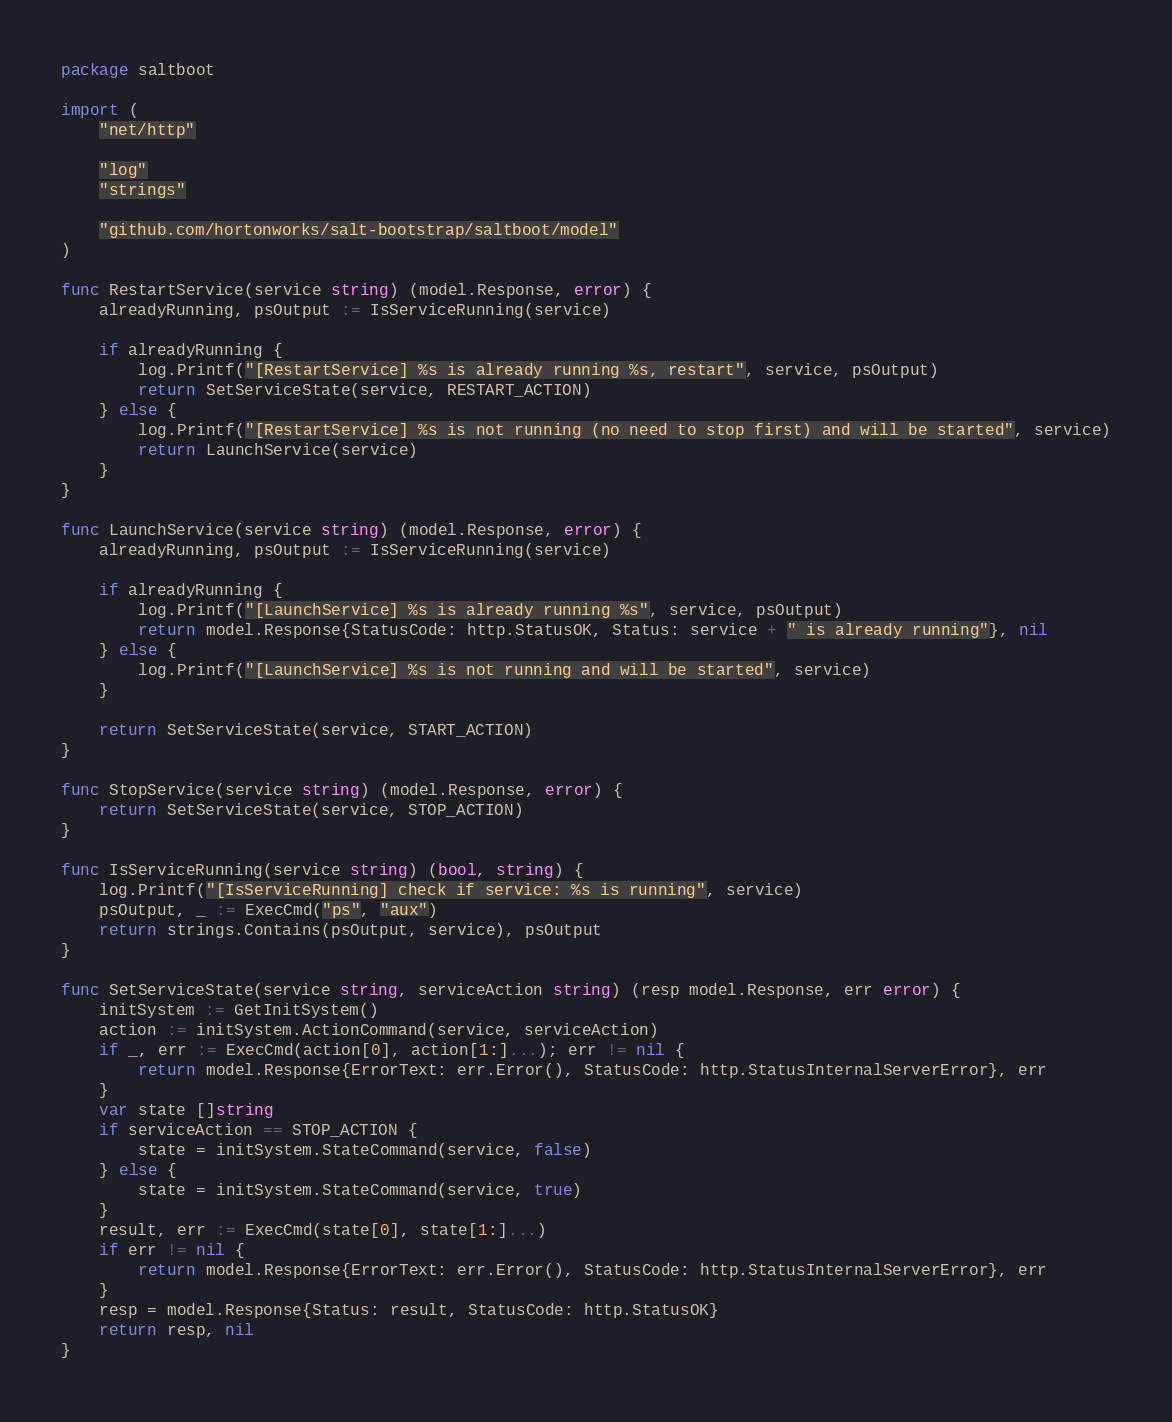Convert code to text. <code><loc_0><loc_0><loc_500><loc_500><_Go_>package saltboot

import (
	"net/http"

	"log"
	"strings"

	"github.com/hortonworks/salt-bootstrap/saltboot/model"
)

func RestartService(service string) (model.Response, error) {
	alreadyRunning, psOutput := IsServiceRunning(service)

	if alreadyRunning {
		log.Printf("[RestartService] %s is already running %s, restart", service, psOutput)
		return SetServiceState(service, RESTART_ACTION)
	} else {
		log.Printf("[RestartService] %s is not running (no need to stop first) and will be started", service)
		return LaunchService(service)
	}
}

func LaunchService(service string) (model.Response, error) {
	alreadyRunning, psOutput := IsServiceRunning(service)

	if alreadyRunning {
		log.Printf("[LaunchService] %s is already running %s", service, psOutput)
		return model.Response{StatusCode: http.StatusOK, Status: service + " is already running"}, nil
	} else {
		log.Printf("[LaunchService] %s is not running and will be started", service)
	}

	return SetServiceState(service, START_ACTION)
}

func StopService(service string) (model.Response, error) {
	return SetServiceState(service, STOP_ACTION)
}

func IsServiceRunning(service string) (bool, string) {
	log.Printf("[IsServiceRunning] check if service: %s is running", service)
	psOutput, _ := ExecCmd("ps", "aux")
	return strings.Contains(psOutput, service), psOutput
}

func SetServiceState(service string, serviceAction string) (resp model.Response, err error) {
	initSystem := GetInitSystem()
	action := initSystem.ActionCommand(service, serviceAction)
	if _, err := ExecCmd(action[0], action[1:]...); err != nil {
		return model.Response{ErrorText: err.Error(), StatusCode: http.StatusInternalServerError}, err
	}
	var state []string
	if serviceAction == STOP_ACTION {
		state = initSystem.StateCommand(service, false)
	} else {
		state = initSystem.StateCommand(service, true)
	}
	result, err := ExecCmd(state[0], state[1:]...)
	if err != nil {
		return model.Response{ErrorText: err.Error(), StatusCode: http.StatusInternalServerError}, err
	}
	resp = model.Response{Status: result, StatusCode: http.StatusOK}
	return resp, nil
}
</code> 